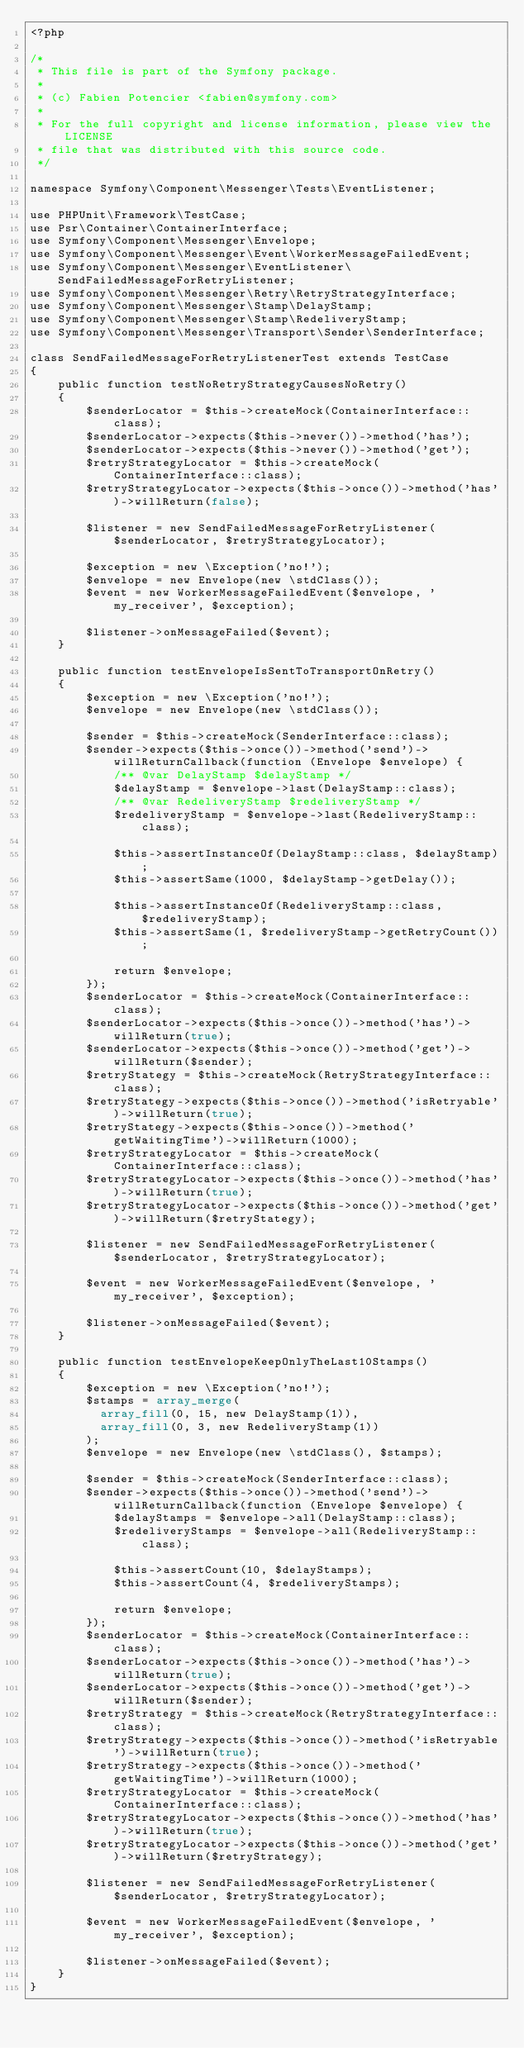<code> <loc_0><loc_0><loc_500><loc_500><_PHP_><?php

/*
 * This file is part of the Symfony package.
 *
 * (c) Fabien Potencier <fabien@symfony.com>
 *
 * For the full copyright and license information, please view the LICENSE
 * file that was distributed with this source code.
 */

namespace Symfony\Component\Messenger\Tests\EventListener;

use PHPUnit\Framework\TestCase;
use Psr\Container\ContainerInterface;
use Symfony\Component\Messenger\Envelope;
use Symfony\Component\Messenger\Event\WorkerMessageFailedEvent;
use Symfony\Component\Messenger\EventListener\SendFailedMessageForRetryListener;
use Symfony\Component\Messenger\Retry\RetryStrategyInterface;
use Symfony\Component\Messenger\Stamp\DelayStamp;
use Symfony\Component\Messenger\Stamp\RedeliveryStamp;
use Symfony\Component\Messenger\Transport\Sender\SenderInterface;

class SendFailedMessageForRetryListenerTest extends TestCase
{
    public function testNoRetryStrategyCausesNoRetry()
    {
        $senderLocator = $this->createMock(ContainerInterface::class);
        $senderLocator->expects($this->never())->method('has');
        $senderLocator->expects($this->never())->method('get');
        $retryStrategyLocator = $this->createMock(ContainerInterface::class);
        $retryStrategyLocator->expects($this->once())->method('has')->willReturn(false);

        $listener = new SendFailedMessageForRetryListener($senderLocator, $retryStrategyLocator);

        $exception = new \Exception('no!');
        $envelope = new Envelope(new \stdClass());
        $event = new WorkerMessageFailedEvent($envelope, 'my_receiver', $exception);

        $listener->onMessageFailed($event);
    }

    public function testEnvelopeIsSentToTransportOnRetry()
    {
        $exception = new \Exception('no!');
        $envelope = new Envelope(new \stdClass());

        $sender = $this->createMock(SenderInterface::class);
        $sender->expects($this->once())->method('send')->willReturnCallback(function (Envelope $envelope) {
            /** @var DelayStamp $delayStamp */
            $delayStamp = $envelope->last(DelayStamp::class);
            /** @var RedeliveryStamp $redeliveryStamp */
            $redeliveryStamp = $envelope->last(RedeliveryStamp::class);

            $this->assertInstanceOf(DelayStamp::class, $delayStamp);
            $this->assertSame(1000, $delayStamp->getDelay());

            $this->assertInstanceOf(RedeliveryStamp::class, $redeliveryStamp);
            $this->assertSame(1, $redeliveryStamp->getRetryCount());

            return $envelope;
        });
        $senderLocator = $this->createMock(ContainerInterface::class);
        $senderLocator->expects($this->once())->method('has')->willReturn(true);
        $senderLocator->expects($this->once())->method('get')->willReturn($sender);
        $retryStategy = $this->createMock(RetryStrategyInterface::class);
        $retryStategy->expects($this->once())->method('isRetryable')->willReturn(true);
        $retryStategy->expects($this->once())->method('getWaitingTime')->willReturn(1000);
        $retryStrategyLocator = $this->createMock(ContainerInterface::class);
        $retryStrategyLocator->expects($this->once())->method('has')->willReturn(true);
        $retryStrategyLocator->expects($this->once())->method('get')->willReturn($retryStategy);

        $listener = new SendFailedMessageForRetryListener($senderLocator, $retryStrategyLocator);

        $event = new WorkerMessageFailedEvent($envelope, 'my_receiver', $exception);

        $listener->onMessageFailed($event);
    }

    public function testEnvelopeKeepOnlyTheLast10Stamps()
    {
        $exception = new \Exception('no!');
        $stamps = array_merge(
          array_fill(0, 15, new DelayStamp(1)),
          array_fill(0, 3, new RedeliveryStamp(1))
        );
        $envelope = new Envelope(new \stdClass(), $stamps);

        $sender = $this->createMock(SenderInterface::class);
        $sender->expects($this->once())->method('send')->willReturnCallback(function (Envelope $envelope) {
            $delayStamps = $envelope->all(DelayStamp::class);
            $redeliveryStamps = $envelope->all(RedeliveryStamp::class);

            $this->assertCount(10, $delayStamps);
            $this->assertCount(4, $redeliveryStamps);

            return $envelope;
        });
        $senderLocator = $this->createMock(ContainerInterface::class);
        $senderLocator->expects($this->once())->method('has')->willReturn(true);
        $senderLocator->expects($this->once())->method('get')->willReturn($sender);
        $retryStrategy = $this->createMock(RetryStrategyInterface::class);
        $retryStrategy->expects($this->once())->method('isRetryable')->willReturn(true);
        $retryStrategy->expects($this->once())->method('getWaitingTime')->willReturn(1000);
        $retryStrategyLocator = $this->createMock(ContainerInterface::class);
        $retryStrategyLocator->expects($this->once())->method('has')->willReturn(true);
        $retryStrategyLocator->expects($this->once())->method('get')->willReturn($retryStrategy);

        $listener = new SendFailedMessageForRetryListener($senderLocator, $retryStrategyLocator);

        $event = new WorkerMessageFailedEvent($envelope, 'my_receiver', $exception);

        $listener->onMessageFailed($event);
    }
}
</code> 